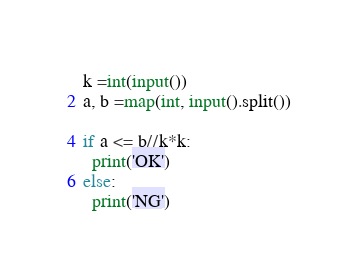Convert code to text. <code><loc_0><loc_0><loc_500><loc_500><_Python_>k =int(input())
a, b =map(int, input().split())

if a <= b//k*k:
  print('OK')
else:
  print('NG')
</code> 